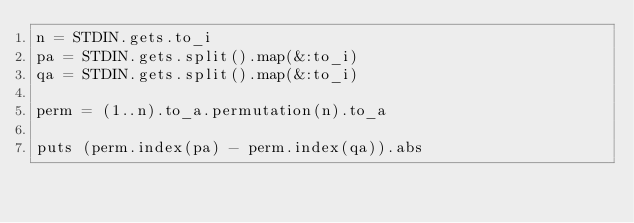Convert code to text. <code><loc_0><loc_0><loc_500><loc_500><_Ruby_>n = STDIN.gets.to_i
pa = STDIN.gets.split().map(&:to_i)
qa = STDIN.gets.split().map(&:to_i)

perm = (1..n).to_a.permutation(n).to_a

puts (perm.index(pa) - perm.index(qa)).abs</code> 